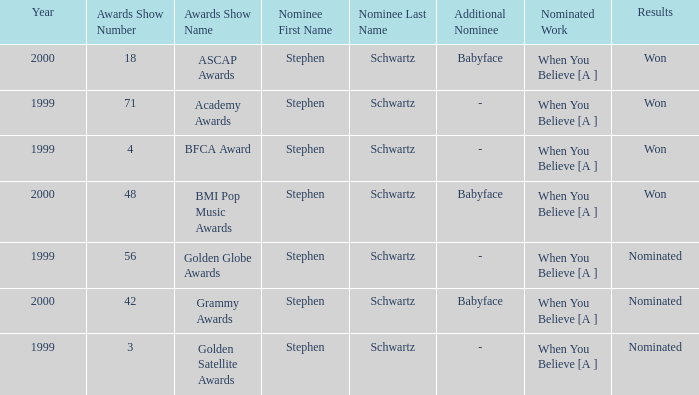What were the outcomes of the 71st academy awards ceremony? Won. 